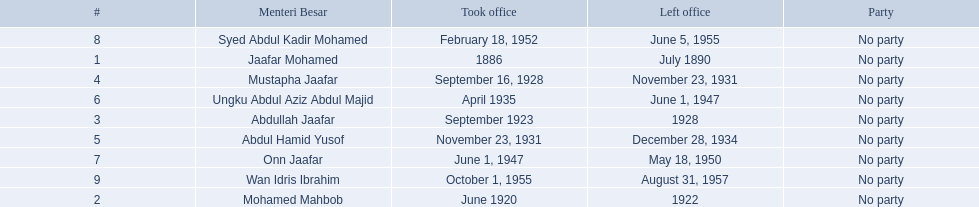Who were all of the menteri besars? Jaafar Mohamed, Mohamed Mahbob, Abdullah Jaafar, Mustapha Jaafar, Abdul Hamid Yusof, Ungku Abdul Aziz Abdul Majid, Onn Jaafar, Syed Abdul Kadir Mohamed, Wan Idris Ibrahim. When did they take office? 1886, June 1920, September 1923, September 16, 1928, November 23, 1931, April 1935, June 1, 1947, February 18, 1952, October 1, 1955. And when did they leave? July 1890, 1922, 1928, November 23, 1931, December 28, 1934, June 1, 1947, May 18, 1950, June 5, 1955, August 31, 1957. Now, who was in office for less than four years? Mohamed Mahbob. 